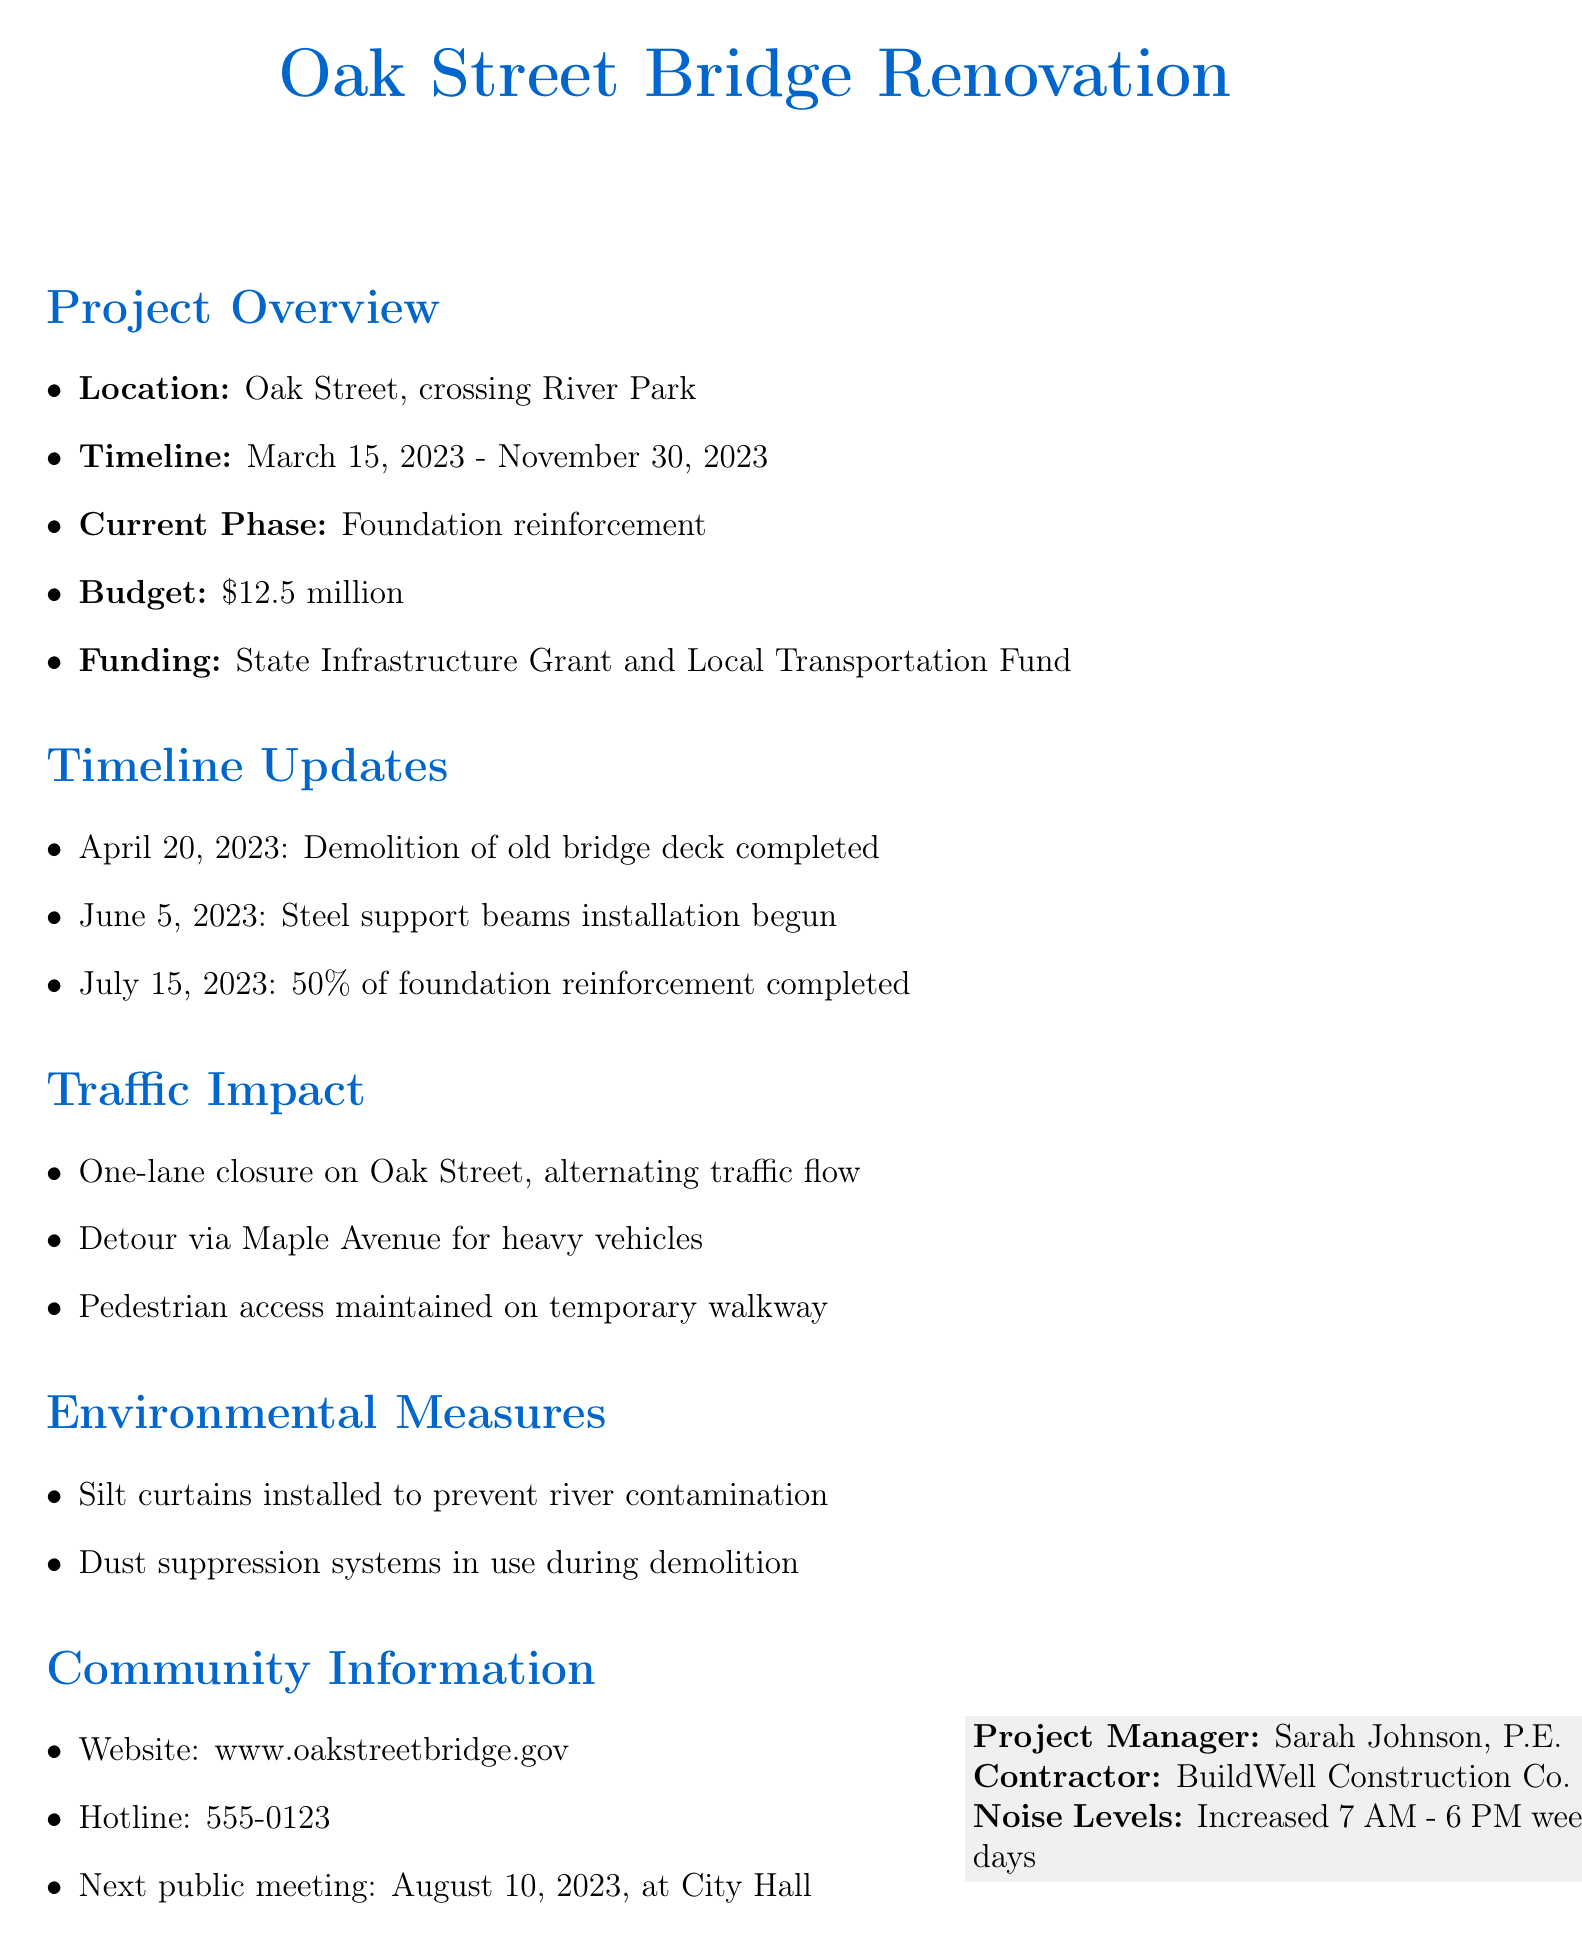What is the project name? The project name is explicitly stated at the beginning of the document, which is the "Oak Street Bridge Renovation."
Answer: Oak Street Bridge Renovation When is the expected completion date? The expected completion date is provided in the project overview section of the document.
Answer: November 30, 2023 What is the current phase of the project? The current phase is mentioned under the project overview, indicating the stage of work being done.
Answer: Foundation reinforcement Who is the project manager? The document specifies the name of the project manager in the section highlighting project details.
Answer: Sarah Johnson, P.E What traffic changes are occurring due to the project? The document lists specific impacts on traffic related to the construction project.
Answer: One-lane closure on Oak Street, alternating traffic flow What measures are in place to protect the environment? The environmental measures section outlines actions taken to mitigate environmental impact.
Answer: Silt curtains installed to prevent river contamination What is the budget for the project? The budget is included in the project overview, giving a clear financial figure allocated for the renovation.
Answer: $12.5 million When is the next public meeting scheduled? The next public meeting date is specified in the community information section of the document.
Answer: August 10, 2023 What is the contractor's name? The contractor's name is mentioned in the project details, providing insight into who is responsible for the construction.
Answer: BuildWell Construction Co 